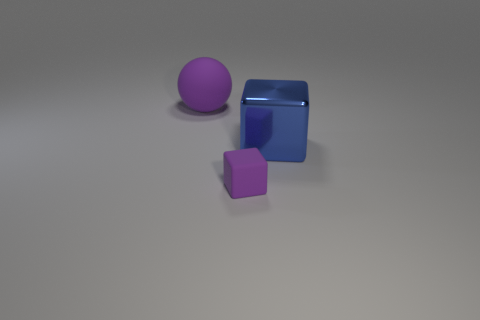Are the large object behind the blue shiny object and the purple thing in front of the big rubber object made of the same material?
Your answer should be very brief. Yes. Are there any other things that are the same shape as the big purple matte object?
Provide a short and direct response. No. What is the color of the metallic cube?
Offer a terse response. Blue. What number of other blue objects have the same shape as the metallic object?
Make the answer very short. 0. The thing that is the same size as the metal cube is what color?
Your answer should be very brief. Purple. Are any yellow metallic things visible?
Offer a very short reply. No. What is the shape of the large thing to the right of the small rubber object?
Your answer should be compact. Cube. How many things are both on the left side of the metallic thing and in front of the sphere?
Offer a terse response. 1. Is there a cube made of the same material as the large sphere?
Provide a succinct answer. Yes. What is the size of the sphere that is the same color as the small cube?
Provide a succinct answer. Large. 